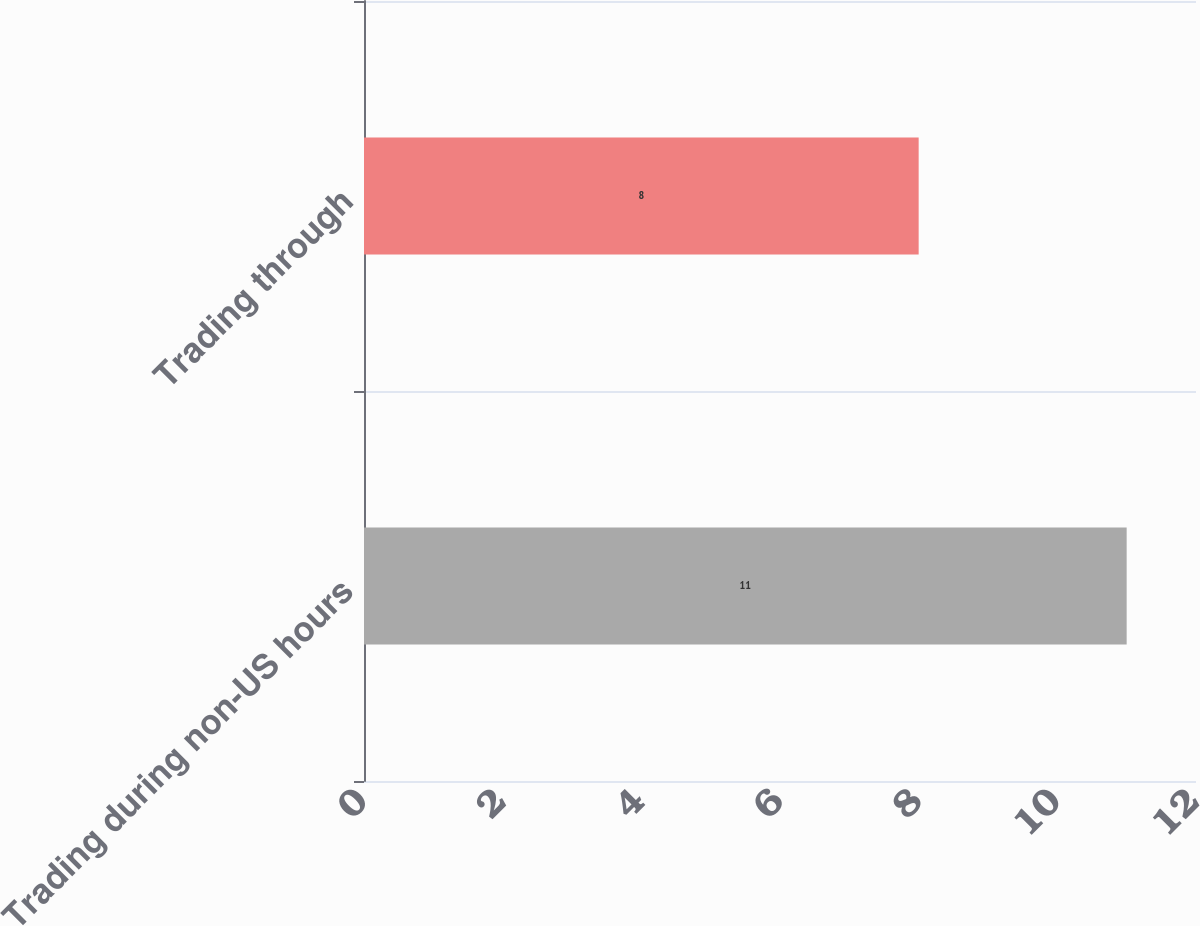Convert chart. <chart><loc_0><loc_0><loc_500><loc_500><bar_chart><fcel>Trading during non-US hours<fcel>Trading through<nl><fcel>11<fcel>8<nl></chart> 